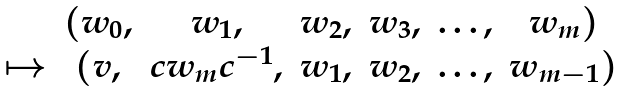<formula> <loc_0><loc_0><loc_500><loc_500>\begin{matrix} & ( w _ { 0 } , & w _ { 1 } , & w _ { 2 } , & w _ { 3 } , & \dots , & w _ { m } ) \\ \mapsto & ( v , & c w _ { m } c ^ { - 1 } , & w _ { 1 } , & w _ { 2 } , & \dots , & w _ { m - 1 } ) \end{matrix}</formula> 